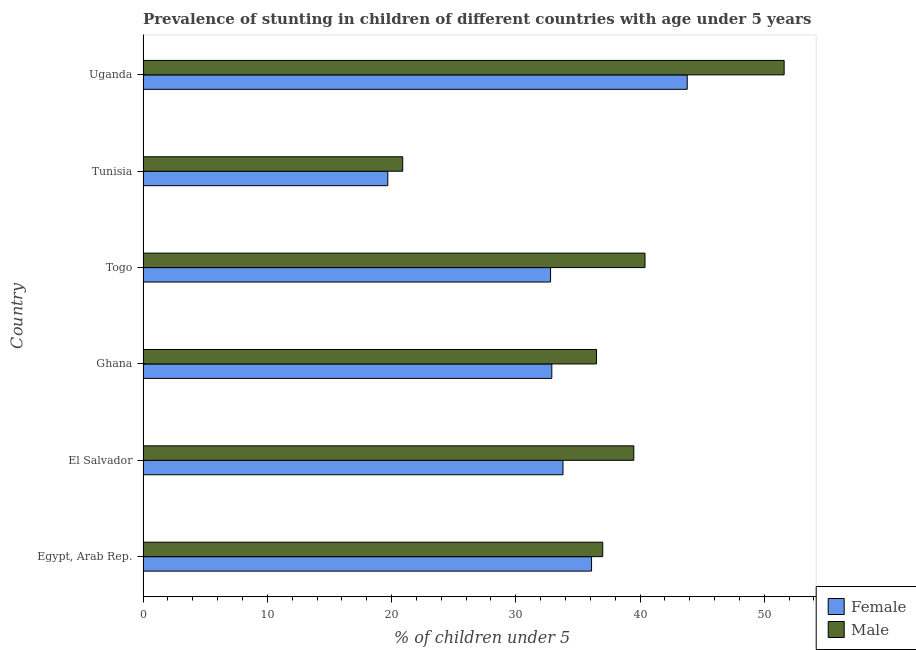How many different coloured bars are there?
Provide a succinct answer. 2. How many groups of bars are there?
Your answer should be very brief. 6. Are the number of bars per tick equal to the number of legend labels?
Make the answer very short. Yes. Are the number of bars on each tick of the Y-axis equal?
Your answer should be compact. Yes. What is the label of the 5th group of bars from the top?
Give a very brief answer. El Salvador. In how many cases, is the number of bars for a given country not equal to the number of legend labels?
Give a very brief answer. 0. What is the percentage of stunted male children in Togo?
Offer a very short reply. 40.4. Across all countries, what is the maximum percentage of stunted male children?
Provide a short and direct response. 51.6. Across all countries, what is the minimum percentage of stunted female children?
Give a very brief answer. 19.7. In which country was the percentage of stunted female children maximum?
Give a very brief answer. Uganda. In which country was the percentage of stunted male children minimum?
Ensure brevity in your answer.  Tunisia. What is the total percentage of stunted female children in the graph?
Provide a short and direct response. 199.1. What is the difference between the percentage of stunted male children in Togo and the percentage of stunted female children in Uganda?
Offer a very short reply. -3.4. What is the average percentage of stunted male children per country?
Give a very brief answer. 37.65. What is the difference between the percentage of stunted female children and percentage of stunted male children in Togo?
Give a very brief answer. -7.6. In how many countries, is the percentage of stunted male children greater than 18 %?
Offer a terse response. 6. What is the ratio of the percentage of stunted male children in El Salvador to that in Ghana?
Your answer should be very brief. 1.08. Is the percentage of stunted female children in El Salvador less than that in Togo?
Make the answer very short. No. What is the difference between the highest and the lowest percentage of stunted male children?
Give a very brief answer. 30.7. Is the sum of the percentage of stunted male children in Ghana and Tunisia greater than the maximum percentage of stunted female children across all countries?
Your answer should be compact. Yes. What does the 2nd bar from the bottom in Tunisia represents?
Offer a very short reply. Male. Are all the bars in the graph horizontal?
Offer a very short reply. Yes. How many countries are there in the graph?
Your answer should be compact. 6. Does the graph contain any zero values?
Your answer should be compact. No. Does the graph contain grids?
Offer a very short reply. No. How many legend labels are there?
Offer a very short reply. 2. What is the title of the graph?
Provide a succinct answer. Prevalence of stunting in children of different countries with age under 5 years. Does "Grants" appear as one of the legend labels in the graph?
Keep it short and to the point. No. What is the label or title of the X-axis?
Your answer should be very brief.  % of children under 5. What is the  % of children under 5 in Female in Egypt, Arab Rep.?
Offer a very short reply. 36.1. What is the  % of children under 5 of Female in El Salvador?
Offer a very short reply. 33.8. What is the  % of children under 5 of Male in El Salvador?
Offer a very short reply. 39.5. What is the  % of children under 5 of Female in Ghana?
Provide a short and direct response. 32.9. What is the  % of children under 5 of Male in Ghana?
Ensure brevity in your answer.  36.5. What is the  % of children under 5 in Female in Togo?
Make the answer very short. 32.8. What is the  % of children under 5 of Male in Togo?
Your answer should be very brief. 40.4. What is the  % of children under 5 of Female in Tunisia?
Keep it short and to the point. 19.7. What is the  % of children under 5 of Male in Tunisia?
Make the answer very short. 20.9. What is the  % of children under 5 of Female in Uganda?
Keep it short and to the point. 43.8. What is the  % of children under 5 of Male in Uganda?
Offer a very short reply. 51.6. Across all countries, what is the maximum  % of children under 5 of Female?
Your answer should be compact. 43.8. Across all countries, what is the maximum  % of children under 5 in Male?
Give a very brief answer. 51.6. Across all countries, what is the minimum  % of children under 5 in Female?
Keep it short and to the point. 19.7. Across all countries, what is the minimum  % of children under 5 in Male?
Offer a terse response. 20.9. What is the total  % of children under 5 of Female in the graph?
Provide a succinct answer. 199.1. What is the total  % of children under 5 in Male in the graph?
Your answer should be compact. 225.9. What is the difference between the  % of children under 5 of Male in Egypt, Arab Rep. and that in El Salvador?
Your response must be concise. -2.5. What is the difference between the  % of children under 5 in Female in Egypt, Arab Rep. and that in Ghana?
Provide a short and direct response. 3.2. What is the difference between the  % of children under 5 of Female in Egypt, Arab Rep. and that in Togo?
Keep it short and to the point. 3.3. What is the difference between the  % of children under 5 in Male in Egypt, Arab Rep. and that in Togo?
Provide a succinct answer. -3.4. What is the difference between the  % of children under 5 of Female in Egypt, Arab Rep. and that in Tunisia?
Your answer should be compact. 16.4. What is the difference between the  % of children under 5 in Male in Egypt, Arab Rep. and that in Uganda?
Offer a very short reply. -14.6. What is the difference between the  % of children under 5 of Female in El Salvador and that in Togo?
Your answer should be compact. 1. What is the difference between the  % of children under 5 of Male in El Salvador and that in Togo?
Your answer should be very brief. -0.9. What is the difference between the  % of children under 5 of Female in El Salvador and that in Tunisia?
Your answer should be very brief. 14.1. What is the difference between the  % of children under 5 in Female in El Salvador and that in Uganda?
Provide a succinct answer. -10. What is the difference between the  % of children under 5 in Female in Ghana and that in Togo?
Give a very brief answer. 0.1. What is the difference between the  % of children under 5 of Male in Ghana and that in Togo?
Offer a terse response. -3.9. What is the difference between the  % of children under 5 in Male in Ghana and that in Uganda?
Provide a short and direct response. -15.1. What is the difference between the  % of children under 5 of Female in Tunisia and that in Uganda?
Provide a short and direct response. -24.1. What is the difference between the  % of children under 5 of Male in Tunisia and that in Uganda?
Offer a terse response. -30.7. What is the difference between the  % of children under 5 in Female in Egypt, Arab Rep. and the  % of children under 5 in Male in Uganda?
Offer a very short reply. -15.5. What is the difference between the  % of children under 5 of Female in El Salvador and the  % of children under 5 of Male in Ghana?
Ensure brevity in your answer.  -2.7. What is the difference between the  % of children under 5 in Female in El Salvador and the  % of children under 5 in Male in Togo?
Give a very brief answer. -6.6. What is the difference between the  % of children under 5 of Female in El Salvador and the  % of children under 5 of Male in Uganda?
Offer a very short reply. -17.8. What is the difference between the  % of children under 5 in Female in Ghana and the  % of children under 5 in Male in Togo?
Provide a succinct answer. -7.5. What is the difference between the  % of children under 5 in Female in Ghana and the  % of children under 5 in Male in Tunisia?
Provide a short and direct response. 12. What is the difference between the  % of children under 5 of Female in Ghana and the  % of children under 5 of Male in Uganda?
Your response must be concise. -18.7. What is the difference between the  % of children under 5 in Female in Togo and the  % of children under 5 in Male in Uganda?
Offer a very short reply. -18.8. What is the difference between the  % of children under 5 in Female in Tunisia and the  % of children under 5 in Male in Uganda?
Offer a very short reply. -31.9. What is the average  % of children under 5 of Female per country?
Your answer should be compact. 33.18. What is the average  % of children under 5 in Male per country?
Provide a short and direct response. 37.65. What is the difference between the  % of children under 5 of Female and  % of children under 5 of Male in El Salvador?
Ensure brevity in your answer.  -5.7. What is the difference between the  % of children under 5 of Female and  % of children under 5 of Male in Ghana?
Ensure brevity in your answer.  -3.6. What is the difference between the  % of children under 5 in Female and  % of children under 5 in Male in Togo?
Ensure brevity in your answer.  -7.6. What is the ratio of the  % of children under 5 of Female in Egypt, Arab Rep. to that in El Salvador?
Provide a short and direct response. 1.07. What is the ratio of the  % of children under 5 in Male in Egypt, Arab Rep. to that in El Salvador?
Make the answer very short. 0.94. What is the ratio of the  % of children under 5 of Female in Egypt, Arab Rep. to that in Ghana?
Provide a succinct answer. 1.1. What is the ratio of the  % of children under 5 in Male in Egypt, Arab Rep. to that in Ghana?
Ensure brevity in your answer.  1.01. What is the ratio of the  % of children under 5 in Female in Egypt, Arab Rep. to that in Togo?
Ensure brevity in your answer.  1.1. What is the ratio of the  % of children under 5 in Male in Egypt, Arab Rep. to that in Togo?
Your response must be concise. 0.92. What is the ratio of the  % of children under 5 of Female in Egypt, Arab Rep. to that in Tunisia?
Give a very brief answer. 1.83. What is the ratio of the  % of children under 5 in Male in Egypt, Arab Rep. to that in Tunisia?
Offer a very short reply. 1.77. What is the ratio of the  % of children under 5 in Female in Egypt, Arab Rep. to that in Uganda?
Provide a succinct answer. 0.82. What is the ratio of the  % of children under 5 of Male in Egypt, Arab Rep. to that in Uganda?
Offer a very short reply. 0.72. What is the ratio of the  % of children under 5 of Female in El Salvador to that in Ghana?
Provide a succinct answer. 1.03. What is the ratio of the  % of children under 5 in Male in El Salvador to that in Ghana?
Provide a succinct answer. 1.08. What is the ratio of the  % of children under 5 of Female in El Salvador to that in Togo?
Give a very brief answer. 1.03. What is the ratio of the  % of children under 5 of Male in El Salvador to that in Togo?
Provide a short and direct response. 0.98. What is the ratio of the  % of children under 5 of Female in El Salvador to that in Tunisia?
Provide a short and direct response. 1.72. What is the ratio of the  % of children under 5 of Male in El Salvador to that in Tunisia?
Make the answer very short. 1.89. What is the ratio of the  % of children under 5 in Female in El Salvador to that in Uganda?
Make the answer very short. 0.77. What is the ratio of the  % of children under 5 of Male in El Salvador to that in Uganda?
Give a very brief answer. 0.77. What is the ratio of the  % of children under 5 in Female in Ghana to that in Togo?
Keep it short and to the point. 1. What is the ratio of the  % of children under 5 of Male in Ghana to that in Togo?
Give a very brief answer. 0.9. What is the ratio of the  % of children under 5 of Female in Ghana to that in Tunisia?
Provide a short and direct response. 1.67. What is the ratio of the  % of children under 5 of Male in Ghana to that in Tunisia?
Your answer should be compact. 1.75. What is the ratio of the  % of children under 5 of Female in Ghana to that in Uganda?
Give a very brief answer. 0.75. What is the ratio of the  % of children under 5 of Male in Ghana to that in Uganda?
Provide a short and direct response. 0.71. What is the ratio of the  % of children under 5 of Female in Togo to that in Tunisia?
Provide a short and direct response. 1.67. What is the ratio of the  % of children under 5 in Male in Togo to that in Tunisia?
Offer a terse response. 1.93. What is the ratio of the  % of children under 5 in Female in Togo to that in Uganda?
Your response must be concise. 0.75. What is the ratio of the  % of children under 5 in Male in Togo to that in Uganda?
Provide a succinct answer. 0.78. What is the ratio of the  % of children under 5 of Female in Tunisia to that in Uganda?
Provide a succinct answer. 0.45. What is the ratio of the  % of children under 5 of Male in Tunisia to that in Uganda?
Ensure brevity in your answer.  0.41. What is the difference between the highest and the lowest  % of children under 5 in Female?
Your answer should be compact. 24.1. What is the difference between the highest and the lowest  % of children under 5 in Male?
Your response must be concise. 30.7. 